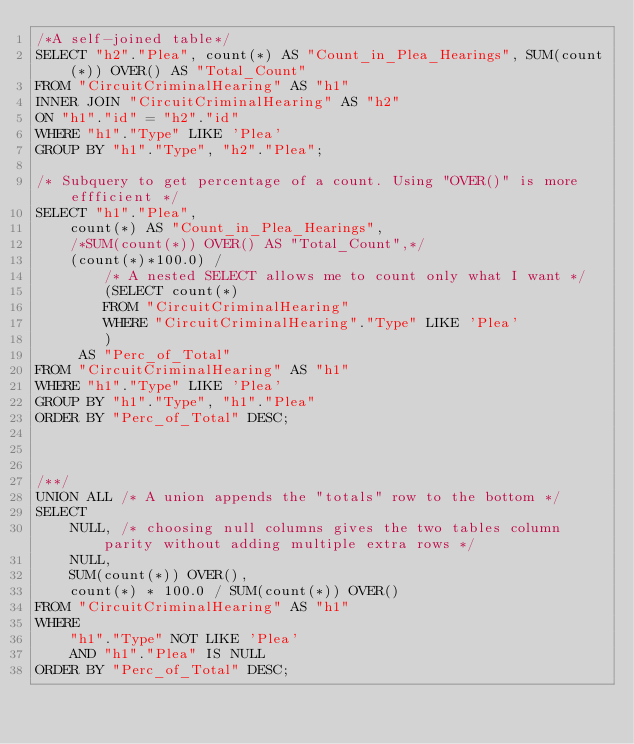<code> <loc_0><loc_0><loc_500><loc_500><_SQL_>/*A self-joined table*/
SELECT "h2"."Plea", count(*) AS "Count_in_Plea_Hearings", SUM(count(*)) OVER() AS "Total_Count"
FROM "CircuitCriminalHearing" AS "h1"
INNER JOIN "CircuitCriminalHearing" AS "h2"
ON "h1"."id" = "h2"."id"
WHERE "h1"."Type" LIKE 'Plea'
GROUP BY "h1"."Type", "h2"."Plea";

/* Subquery to get percentage of a count. Using "OVER()" is more effficient */
SELECT "h1"."Plea", 
	count(*) AS "Count_in_Plea_Hearings", 
	/*SUM(count(*)) OVER() AS "Total_Count",*/
	(count(*)*100.0) / 
		/* A nested SELECT allows me to count only what I want */
		(SELECT count(*)
		FROM "CircuitCriminalHearing"
		WHERE "CircuitCriminalHearing"."Type" LIKE 'Plea'
		)
	 AS "Perc_of_Total"
FROM "CircuitCriminalHearing" AS "h1"
WHERE "h1"."Type" LIKE 'Plea'
GROUP BY "h1"."Type", "h1"."Plea"
ORDER BY "Perc_of_Total" DESC;



/**/
UNION ALL /* A union appends the "totals" row to the bottom */
SELECT 
	NULL, /* choosing null columns gives the two tables column parity without adding multiple extra rows */
	NULL,
	SUM(count(*)) OVER(),
	count(*) * 100.0 / SUM(count(*)) OVER()
FROM "CircuitCriminalHearing" AS "h1"
WHERE 
	"h1"."Type" NOT LIKE 'Plea'
	AND "h1"."Plea" IS NULL
ORDER BY "Perc_of_Total" DESC;

</code> 